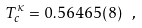<formula> <loc_0><loc_0><loc_500><loc_500>T _ { c } ^ { \kappa } = 0 . 5 6 4 6 5 ( 8 ) \ ,</formula> 